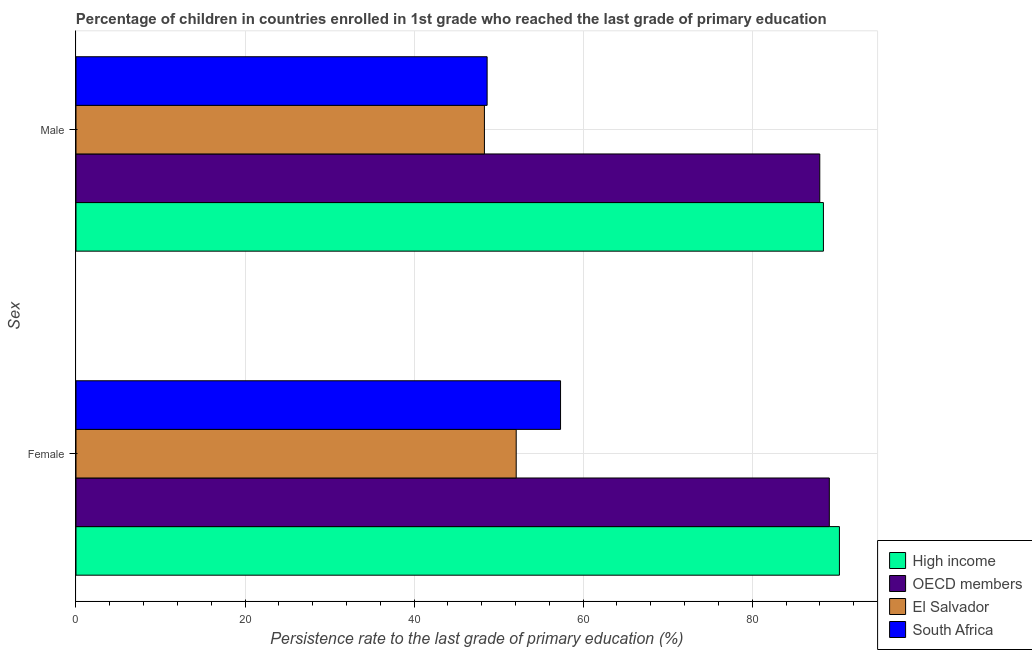How many groups of bars are there?
Make the answer very short. 2. How many bars are there on the 2nd tick from the top?
Offer a terse response. 4. What is the label of the 1st group of bars from the top?
Your answer should be compact. Male. What is the persistence rate of female students in OECD members?
Provide a short and direct response. 89.12. Across all countries, what is the maximum persistence rate of female students?
Offer a very short reply. 90.32. Across all countries, what is the minimum persistence rate of female students?
Provide a succinct answer. 52.08. In which country was the persistence rate of female students maximum?
Make the answer very short. High income. In which country was the persistence rate of female students minimum?
Your answer should be compact. El Salvador. What is the total persistence rate of female students in the graph?
Offer a terse response. 288.85. What is the difference between the persistence rate of female students in South Africa and that in El Salvador?
Ensure brevity in your answer.  5.25. What is the difference between the persistence rate of male students in OECD members and the persistence rate of female students in South Africa?
Provide a short and direct response. 30.67. What is the average persistence rate of female students per country?
Keep it short and to the point. 72.21. What is the difference between the persistence rate of female students and persistence rate of male students in High income?
Make the answer very short. 1.89. What is the ratio of the persistence rate of female students in High income to that in South Africa?
Your answer should be compact. 1.58. Is the persistence rate of male students in South Africa less than that in OECD members?
Make the answer very short. Yes. In how many countries, is the persistence rate of male students greater than the average persistence rate of male students taken over all countries?
Offer a very short reply. 2. What does the 1st bar from the top in Female represents?
Make the answer very short. South Africa. What does the 3rd bar from the bottom in Male represents?
Keep it short and to the point. El Salvador. How many countries are there in the graph?
Your response must be concise. 4. Does the graph contain any zero values?
Ensure brevity in your answer.  No. Where does the legend appear in the graph?
Make the answer very short. Bottom right. How many legend labels are there?
Ensure brevity in your answer.  4. What is the title of the graph?
Offer a very short reply. Percentage of children in countries enrolled in 1st grade who reached the last grade of primary education. Does "Myanmar" appear as one of the legend labels in the graph?
Ensure brevity in your answer.  No. What is the label or title of the X-axis?
Keep it short and to the point. Persistence rate to the last grade of primary education (%). What is the label or title of the Y-axis?
Make the answer very short. Sex. What is the Persistence rate to the last grade of primary education (%) in High income in Female?
Make the answer very short. 90.32. What is the Persistence rate to the last grade of primary education (%) in OECD members in Female?
Offer a very short reply. 89.12. What is the Persistence rate to the last grade of primary education (%) in El Salvador in Female?
Offer a terse response. 52.08. What is the Persistence rate to the last grade of primary education (%) in South Africa in Female?
Keep it short and to the point. 57.33. What is the Persistence rate to the last grade of primary education (%) in High income in Male?
Your answer should be very brief. 88.42. What is the Persistence rate to the last grade of primary education (%) of OECD members in Male?
Keep it short and to the point. 87.99. What is the Persistence rate to the last grade of primary education (%) of El Salvador in Male?
Ensure brevity in your answer.  48.32. What is the Persistence rate to the last grade of primary education (%) of South Africa in Male?
Your answer should be very brief. 48.64. Across all Sex, what is the maximum Persistence rate to the last grade of primary education (%) of High income?
Make the answer very short. 90.32. Across all Sex, what is the maximum Persistence rate to the last grade of primary education (%) of OECD members?
Offer a terse response. 89.12. Across all Sex, what is the maximum Persistence rate to the last grade of primary education (%) in El Salvador?
Offer a very short reply. 52.08. Across all Sex, what is the maximum Persistence rate to the last grade of primary education (%) of South Africa?
Make the answer very short. 57.33. Across all Sex, what is the minimum Persistence rate to the last grade of primary education (%) of High income?
Your answer should be compact. 88.42. Across all Sex, what is the minimum Persistence rate to the last grade of primary education (%) in OECD members?
Make the answer very short. 87.99. Across all Sex, what is the minimum Persistence rate to the last grade of primary education (%) in El Salvador?
Your answer should be compact. 48.32. Across all Sex, what is the minimum Persistence rate to the last grade of primary education (%) in South Africa?
Your answer should be compact. 48.64. What is the total Persistence rate to the last grade of primary education (%) in High income in the graph?
Your answer should be very brief. 178.74. What is the total Persistence rate to the last grade of primary education (%) of OECD members in the graph?
Ensure brevity in your answer.  177.12. What is the total Persistence rate to the last grade of primary education (%) in El Salvador in the graph?
Provide a succinct answer. 100.4. What is the total Persistence rate to the last grade of primary education (%) of South Africa in the graph?
Keep it short and to the point. 105.96. What is the difference between the Persistence rate to the last grade of primary education (%) of High income in Female and that in Male?
Provide a succinct answer. 1.89. What is the difference between the Persistence rate to the last grade of primary education (%) in OECD members in Female and that in Male?
Your answer should be very brief. 1.13. What is the difference between the Persistence rate to the last grade of primary education (%) in El Salvador in Female and that in Male?
Keep it short and to the point. 3.76. What is the difference between the Persistence rate to the last grade of primary education (%) of South Africa in Female and that in Male?
Offer a terse response. 8.69. What is the difference between the Persistence rate to the last grade of primary education (%) of High income in Female and the Persistence rate to the last grade of primary education (%) of OECD members in Male?
Give a very brief answer. 2.32. What is the difference between the Persistence rate to the last grade of primary education (%) in High income in Female and the Persistence rate to the last grade of primary education (%) in El Salvador in Male?
Ensure brevity in your answer.  42. What is the difference between the Persistence rate to the last grade of primary education (%) of High income in Female and the Persistence rate to the last grade of primary education (%) of South Africa in Male?
Offer a very short reply. 41.68. What is the difference between the Persistence rate to the last grade of primary education (%) in OECD members in Female and the Persistence rate to the last grade of primary education (%) in El Salvador in Male?
Make the answer very short. 40.8. What is the difference between the Persistence rate to the last grade of primary education (%) of OECD members in Female and the Persistence rate to the last grade of primary education (%) of South Africa in Male?
Give a very brief answer. 40.48. What is the difference between the Persistence rate to the last grade of primary education (%) of El Salvador in Female and the Persistence rate to the last grade of primary education (%) of South Africa in Male?
Your response must be concise. 3.44. What is the average Persistence rate to the last grade of primary education (%) of High income per Sex?
Make the answer very short. 89.37. What is the average Persistence rate to the last grade of primary education (%) in OECD members per Sex?
Offer a very short reply. 88.56. What is the average Persistence rate to the last grade of primary education (%) in El Salvador per Sex?
Offer a very short reply. 50.2. What is the average Persistence rate to the last grade of primary education (%) in South Africa per Sex?
Your answer should be very brief. 52.98. What is the difference between the Persistence rate to the last grade of primary education (%) in High income and Persistence rate to the last grade of primary education (%) in OECD members in Female?
Ensure brevity in your answer.  1.19. What is the difference between the Persistence rate to the last grade of primary education (%) in High income and Persistence rate to the last grade of primary education (%) in El Salvador in Female?
Your response must be concise. 38.24. What is the difference between the Persistence rate to the last grade of primary education (%) of High income and Persistence rate to the last grade of primary education (%) of South Africa in Female?
Give a very brief answer. 32.99. What is the difference between the Persistence rate to the last grade of primary education (%) of OECD members and Persistence rate to the last grade of primary education (%) of El Salvador in Female?
Ensure brevity in your answer.  37.04. What is the difference between the Persistence rate to the last grade of primary education (%) of OECD members and Persistence rate to the last grade of primary education (%) of South Africa in Female?
Your response must be concise. 31.8. What is the difference between the Persistence rate to the last grade of primary education (%) in El Salvador and Persistence rate to the last grade of primary education (%) in South Africa in Female?
Your answer should be compact. -5.25. What is the difference between the Persistence rate to the last grade of primary education (%) in High income and Persistence rate to the last grade of primary education (%) in OECD members in Male?
Offer a terse response. 0.43. What is the difference between the Persistence rate to the last grade of primary education (%) of High income and Persistence rate to the last grade of primary education (%) of El Salvador in Male?
Offer a very short reply. 40.11. What is the difference between the Persistence rate to the last grade of primary education (%) of High income and Persistence rate to the last grade of primary education (%) of South Africa in Male?
Ensure brevity in your answer.  39.78. What is the difference between the Persistence rate to the last grade of primary education (%) in OECD members and Persistence rate to the last grade of primary education (%) in El Salvador in Male?
Ensure brevity in your answer.  39.67. What is the difference between the Persistence rate to the last grade of primary education (%) of OECD members and Persistence rate to the last grade of primary education (%) of South Africa in Male?
Ensure brevity in your answer.  39.35. What is the difference between the Persistence rate to the last grade of primary education (%) in El Salvador and Persistence rate to the last grade of primary education (%) in South Africa in Male?
Provide a succinct answer. -0.32. What is the ratio of the Persistence rate to the last grade of primary education (%) of High income in Female to that in Male?
Ensure brevity in your answer.  1.02. What is the ratio of the Persistence rate to the last grade of primary education (%) in OECD members in Female to that in Male?
Your answer should be compact. 1.01. What is the ratio of the Persistence rate to the last grade of primary education (%) in El Salvador in Female to that in Male?
Keep it short and to the point. 1.08. What is the ratio of the Persistence rate to the last grade of primary education (%) in South Africa in Female to that in Male?
Your answer should be compact. 1.18. What is the difference between the highest and the second highest Persistence rate to the last grade of primary education (%) of High income?
Your answer should be compact. 1.89. What is the difference between the highest and the second highest Persistence rate to the last grade of primary education (%) of OECD members?
Your response must be concise. 1.13. What is the difference between the highest and the second highest Persistence rate to the last grade of primary education (%) in El Salvador?
Offer a very short reply. 3.76. What is the difference between the highest and the second highest Persistence rate to the last grade of primary education (%) in South Africa?
Offer a very short reply. 8.69. What is the difference between the highest and the lowest Persistence rate to the last grade of primary education (%) in High income?
Keep it short and to the point. 1.89. What is the difference between the highest and the lowest Persistence rate to the last grade of primary education (%) of OECD members?
Ensure brevity in your answer.  1.13. What is the difference between the highest and the lowest Persistence rate to the last grade of primary education (%) in El Salvador?
Ensure brevity in your answer.  3.76. What is the difference between the highest and the lowest Persistence rate to the last grade of primary education (%) in South Africa?
Provide a short and direct response. 8.69. 